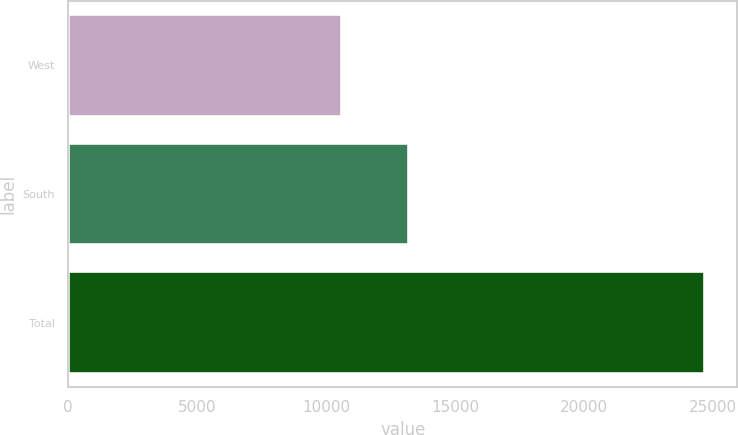Convert chart to OTSL. <chart><loc_0><loc_0><loc_500><loc_500><bar_chart><fcel>West<fcel>South<fcel>Total<nl><fcel>10630<fcel>13219<fcel>24705<nl></chart> 